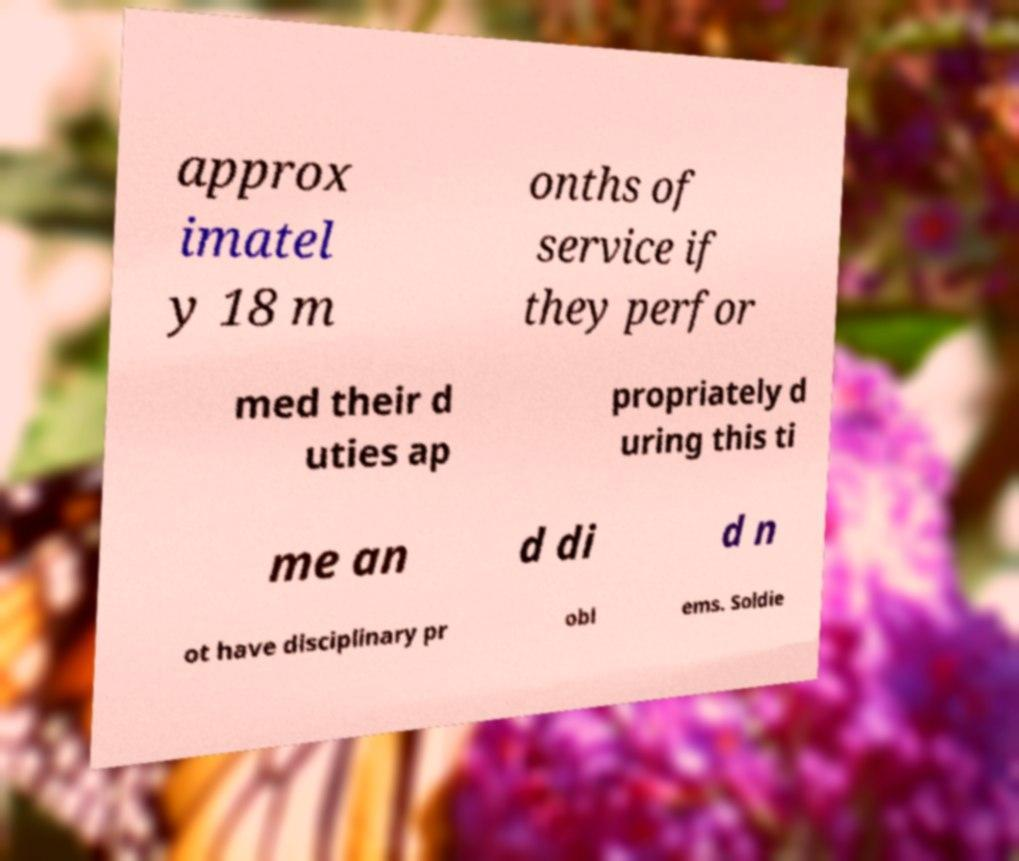Please identify and transcribe the text found in this image. approx imatel y 18 m onths of service if they perfor med their d uties ap propriately d uring this ti me an d di d n ot have disciplinary pr obl ems. Soldie 